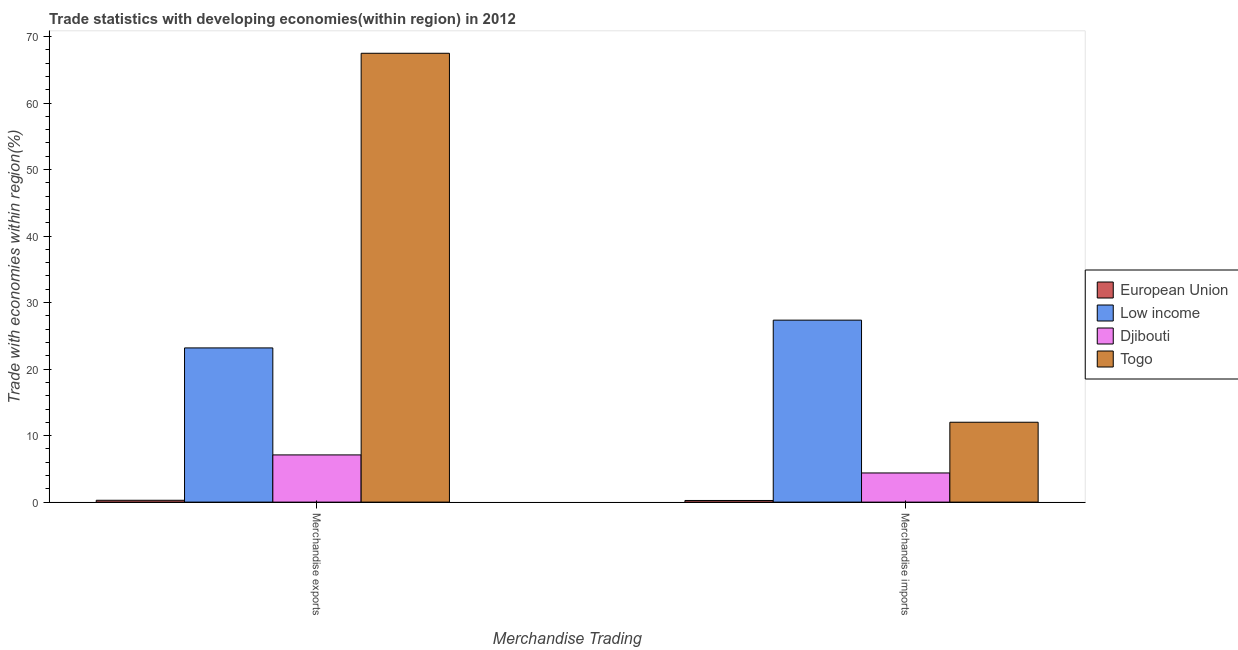Are the number of bars on each tick of the X-axis equal?
Your answer should be compact. Yes. How many bars are there on the 1st tick from the left?
Give a very brief answer. 4. How many bars are there on the 2nd tick from the right?
Your answer should be compact. 4. What is the merchandise imports in Low income?
Offer a very short reply. 27.36. Across all countries, what is the maximum merchandise exports?
Offer a terse response. 67.49. Across all countries, what is the minimum merchandise imports?
Your response must be concise. 0.25. In which country was the merchandise exports maximum?
Provide a succinct answer. Togo. In which country was the merchandise imports minimum?
Keep it short and to the point. European Union. What is the total merchandise exports in the graph?
Give a very brief answer. 98.05. What is the difference between the merchandise exports in European Union and that in Togo?
Give a very brief answer. -67.21. What is the difference between the merchandise imports in Djibouti and the merchandise exports in Low income?
Offer a very short reply. -18.8. What is the average merchandise exports per country?
Keep it short and to the point. 24.51. What is the difference between the merchandise imports and merchandise exports in Low income?
Your response must be concise. 4.18. What is the ratio of the merchandise imports in European Union to that in Togo?
Your response must be concise. 0.02. In how many countries, is the merchandise exports greater than the average merchandise exports taken over all countries?
Make the answer very short. 1. What does the 2nd bar from the left in Merchandise imports represents?
Give a very brief answer. Low income. What does the 1st bar from the right in Merchandise imports represents?
Offer a terse response. Togo. Are all the bars in the graph horizontal?
Your response must be concise. No. How many countries are there in the graph?
Provide a short and direct response. 4. Does the graph contain any zero values?
Keep it short and to the point. No. Where does the legend appear in the graph?
Keep it short and to the point. Center right. How many legend labels are there?
Your answer should be compact. 4. What is the title of the graph?
Ensure brevity in your answer.  Trade statistics with developing economies(within region) in 2012. What is the label or title of the X-axis?
Provide a short and direct response. Merchandise Trading. What is the label or title of the Y-axis?
Provide a succinct answer. Trade with economies within region(%). What is the Trade with economies within region(%) in European Union in Merchandise exports?
Your response must be concise. 0.28. What is the Trade with economies within region(%) in Low income in Merchandise exports?
Keep it short and to the point. 23.18. What is the Trade with economies within region(%) in Djibouti in Merchandise exports?
Offer a very short reply. 7.1. What is the Trade with economies within region(%) in Togo in Merchandise exports?
Make the answer very short. 67.49. What is the Trade with economies within region(%) in European Union in Merchandise imports?
Keep it short and to the point. 0.25. What is the Trade with economies within region(%) of Low income in Merchandise imports?
Offer a terse response. 27.36. What is the Trade with economies within region(%) of Djibouti in Merchandise imports?
Your response must be concise. 4.38. What is the Trade with economies within region(%) in Togo in Merchandise imports?
Give a very brief answer. 12.01. Across all Merchandise Trading, what is the maximum Trade with economies within region(%) of European Union?
Offer a terse response. 0.28. Across all Merchandise Trading, what is the maximum Trade with economies within region(%) in Low income?
Give a very brief answer. 27.36. Across all Merchandise Trading, what is the maximum Trade with economies within region(%) of Djibouti?
Make the answer very short. 7.1. Across all Merchandise Trading, what is the maximum Trade with economies within region(%) in Togo?
Your answer should be compact. 67.49. Across all Merchandise Trading, what is the minimum Trade with economies within region(%) in European Union?
Your answer should be compact. 0.25. Across all Merchandise Trading, what is the minimum Trade with economies within region(%) in Low income?
Make the answer very short. 23.18. Across all Merchandise Trading, what is the minimum Trade with economies within region(%) in Djibouti?
Offer a very short reply. 4.38. Across all Merchandise Trading, what is the minimum Trade with economies within region(%) of Togo?
Offer a terse response. 12.01. What is the total Trade with economies within region(%) in European Union in the graph?
Your answer should be compact. 0.53. What is the total Trade with economies within region(%) of Low income in the graph?
Provide a short and direct response. 50.54. What is the total Trade with economies within region(%) in Djibouti in the graph?
Your response must be concise. 11.48. What is the total Trade with economies within region(%) in Togo in the graph?
Keep it short and to the point. 79.5. What is the difference between the Trade with economies within region(%) of European Union in Merchandise exports and that in Merchandise imports?
Give a very brief answer. 0.03. What is the difference between the Trade with economies within region(%) in Low income in Merchandise exports and that in Merchandise imports?
Your answer should be compact. -4.18. What is the difference between the Trade with economies within region(%) in Djibouti in Merchandise exports and that in Merchandise imports?
Make the answer very short. 2.71. What is the difference between the Trade with economies within region(%) of Togo in Merchandise exports and that in Merchandise imports?
Your response must be concise. 55.48. What is the difference between the Trade with economies within region(%) in European Union in Merchandise exports and the Trade with economies within region(%) in Low income in Merchandise imports?
Make the answer very short. -27.08. What is the difference between the Trade with economies within region(%) in European Union in Merchandise exports and the Trade with economies within region(%) in Djibouti in Merchandise imports?
Give a very brief answer. -4.11. What is the difference between the Trade with economies within region(%) in European Union in Merchandise exports and the Trade with economies within region(%) in Togo in Merchandise imports?
Ensure brevity in your answer.  -11.73. What is the difference between the Trade with economies within region(%) in Low income in Merchandise exports and the Trade with economies within region(%) in Djibouti in Merchandise imports?
Offer a terse response. 18.8. What is the difference between the Trade with economies within region(%) in Low income in Merchandise exports and the Trade with economies within region(%) in Togo in Merchandise imports?
Offer a very short reply. 11.17. What is the difference between the Trade with economies within region(%) in Djibouti in Merchandise exports and the Trade with economies within region(%) in Togo in Merchandise imports?
Make the answer very short. -4.91. What is the average Trade with economies within region(%) in European Union per Merchandise Trading?
Provide a short and direct response. 0.26. What is the average Trade with economies within region(%) in Low income per Merchandise Trading?
Keep it short and to the point. 25.27. What is the average Trade with economies within region(%) of Djibouti per Merchandise Trading?
Provide a short and direct response. 5.74. What is the average Trade with economies within region(%) in Togo per Merchandise Trading?
Give a very brief answer. 39.75. What is the difference between the Trade with economies within region(%) in European Union and Trade with economies within region(%) in Low income in Merchandise exports?
Offer a very short reply. -22.91. What is the difference between the Trade with economies within region(%) of European Union and Trade with economies within region(%) of Djibouti in Merchandise exports?
Offer a terse response. -6.82. What is the difference between the Trade with economies within region(%) in European Union and Trade with economies within region(%) in Togo in Merchandise exports?
Your answer should be very brief. -67.21. What is the difference between the Trade with economies within region(%) in Low income and Trade with economies within region(%) in Djibouti in Merchandise exports?
Provide a succinct answer. 16.09. What is the difference between the Trade with economies within region(%) in Low income and Trade with economies within region(%) in Togo in Merchandise exports?
Offer a very short reply. -44.3. What is the difference between the Trade with economies within region(%) of Djibouti and Trade with economies within region(%) of Togo in Merchandise exports?
Keep it short and to the point. -60.39. What is the difference between the Trade with economies within region(%) of European Union and Trade with economies within region(%) of Low income in Merchandise imports?
Offer a terse response. -27.11. What is the difference between the Trade with economies within region(%) in European Union and Trade with economies within region(%) in Djibouti in Merchandise imports?
Your response must be concise. -4.14. What is the difference between the Trade with economies within region(%) in European Union and Trade with economies within region(%) in Togo in Merchandise imports?
Ensure brevity in your answer.  -11.76. What is the difference between the Trade with economies within region(%) in Low income and Trade with economies within region(%) in Djibouti in Merchandise imports?
Provide a short and direct response. 22.98. What is the difference between the Trade with economies within region(%) of Low income and Trade with economies within region(%) of Togo in Merchandise imports?
Provide a short and direct response. 15.35. What is the difference between the Trade with economies within region(%) in Djibouti and Trade with economies within region(%) in Togo in Merchandise imports?
Your answer should be compact. -7.63. What is the ratio of the Trade with economies within region(%) in European Union in Merchandise exports to that in Merchandise imports?
Make the answer very short. 1.12. What is the ratio of the Trade with economies within region(%) in Low income in Merchandise exports to that in Merchandise imports?
Your answer should be compact. 0.85. What is the ratio of the Trade with economies within region(%) of Djibouti in Merchandise exports to that in Merchandise imports?
Your answer should be compact. 1.62. What is the ratio of the Trade with economies within region(%) of Togo in Merchandise exports to that in Merchandise imports?
Keep it short and to the point. 5.62. What is the difference between the highest and the second highest Trade with economies within region(%) of European Union?
Provide a succinct answer. 0.03. What is the difference between the highest and the second highest Trade with economies within region(%) of Low income?
Your answer should be very brief. 4.18. What is the difference between the highest and the second highest Trade with economies within region(%) of Djibouti?
Offer a very short reply. 2.71. What is the difference between the highest and the second highest Trade with economies within region(%) of Togo?
Make the answer very short. 55.48. What is the difference between the highest and the lowest Trade with economies within region(%) in European Union?
Offer a very short reply. 0.03. What is the difference between the highest and the lowest Trade with economies within region(%) in Low income?
Ensure brevity in your answer.  4.18. What is the difference between the highest and the lowest Trade with economies within region(%) of Djibouti?
Your response must be concise. 2.71. What is the difference between the highest and the lowest Trade with economies within region(%) of Togo?
Your answer should be compact. 55.48. 